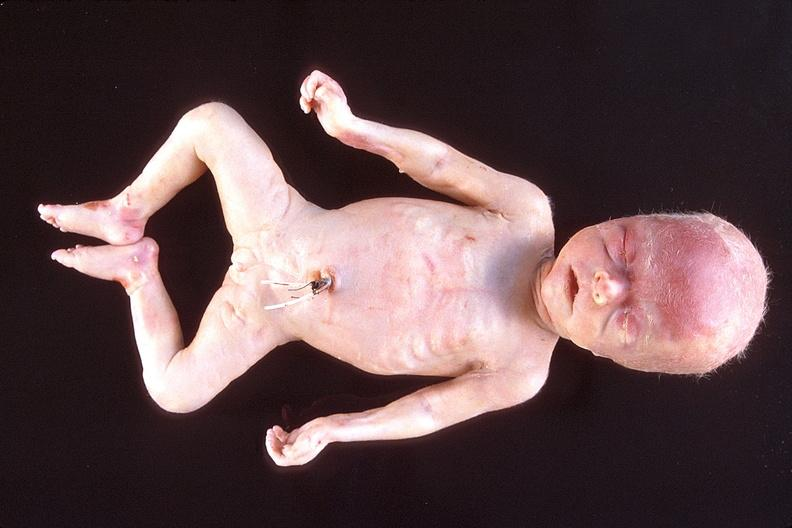does this image show hyaline membrane disease?
Answer the question using a single word or phrase. Yes 